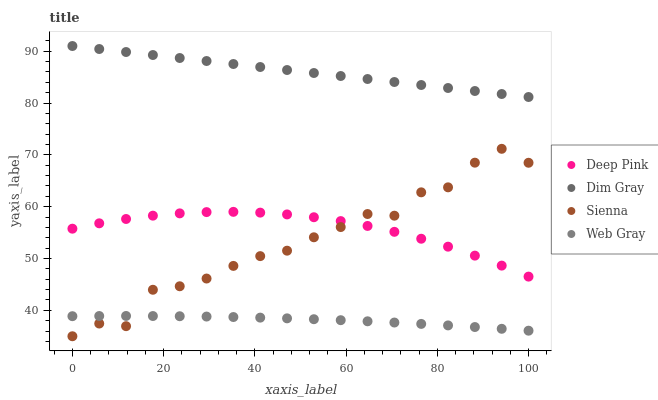Does Web Gray have the minimum area under the curve?
Answer yes or no. Yes. Does Dim Gray have the maximum area under the curve?
Answer yes or no. Yes. Does Deep Pink have the minimum area under the curve?
Answer yes or no. No. Does Deep Pink have the maximum area under the curve?
Answer yes or no. No. Is Dim Gray the smoothest?
Answer yes or no. Yes. Is Sienna the roughest?
Answer yes or no. Yes. Is Deep Pink the smoothest?
Answer yes or no. No. Is Deep Pink the roughest?
Answer yes or no. No. Does Sienna have the lowest value?
Answer yes or no. Yes. Does Deep Pink have the lowest value?
Answer yes or no. No. Does Dim Gray have the highest value?
Answer yes or no. Yes. Does Deep Pink have the highest value?
Answer yes or no. No. Is Web Gray less than Dim Gray?
Answer yes or no. Yes. Is Dim Gray greater than Web Gray?
Answer yes or no. Yes. Does Deep Pink intersect Sienna?
Answer yes or no. Yes. Is Deep Pink less than Sienna?
Answer yes or no. No. Is Deep Pink greater than Sienna?
Answer yes or no. No. Does Web Gray intersect Dim Gray?
Answer yes or no. No. 